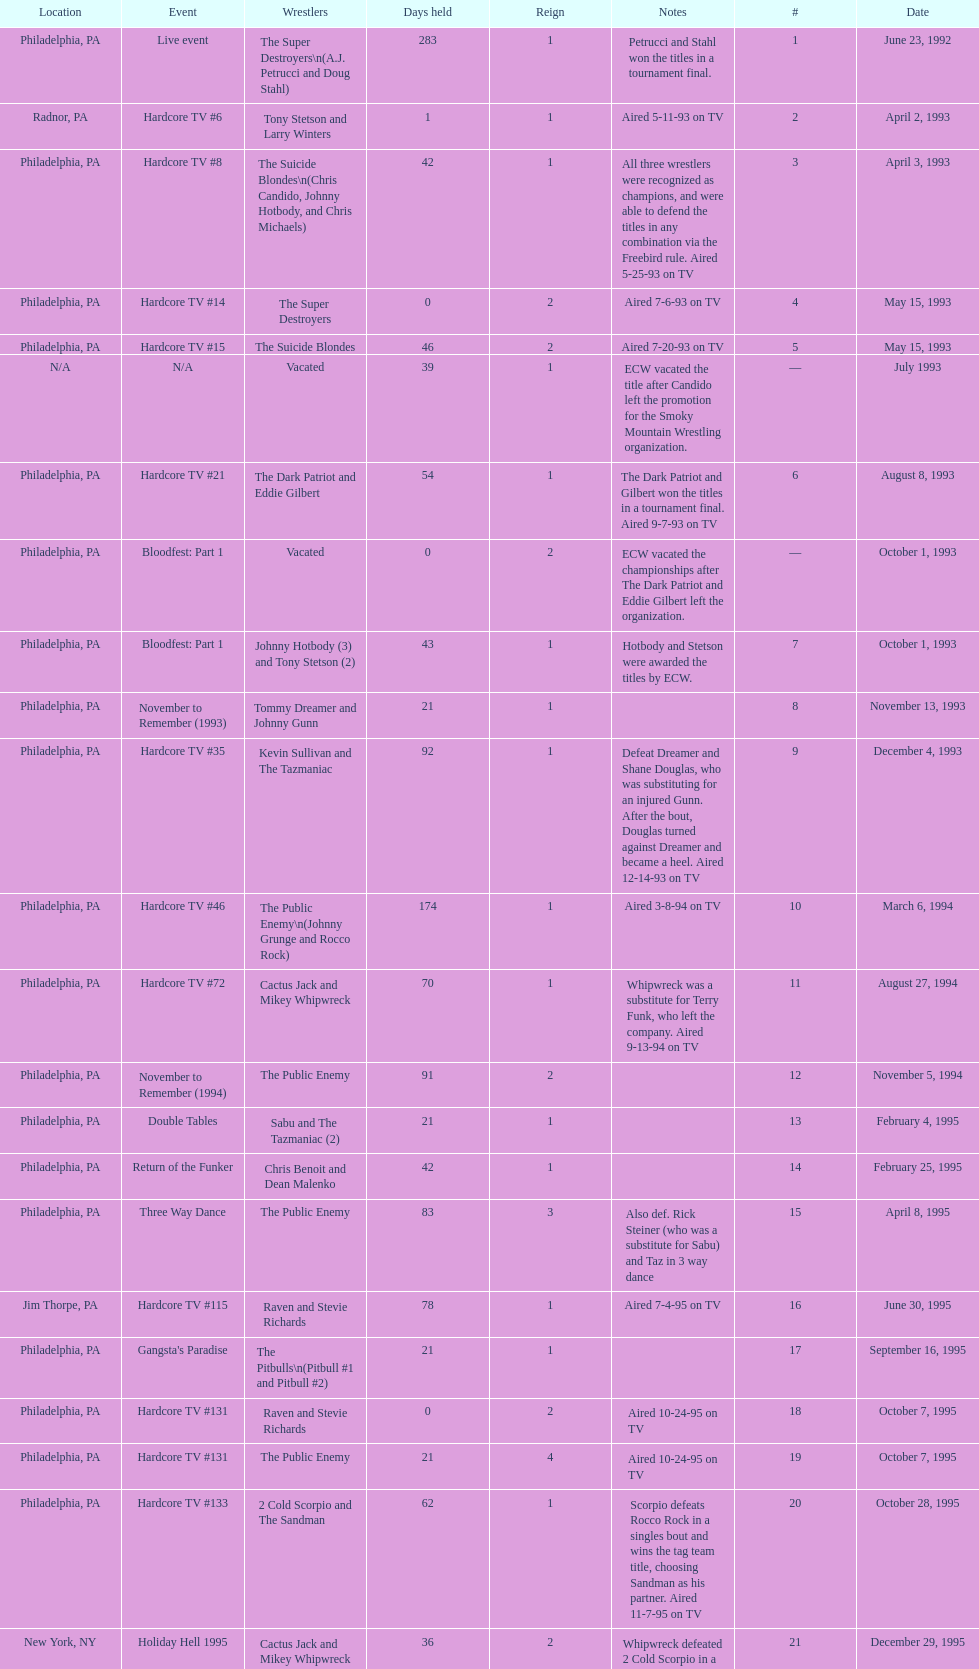How many days did hardcore tv #6 take? 1. 